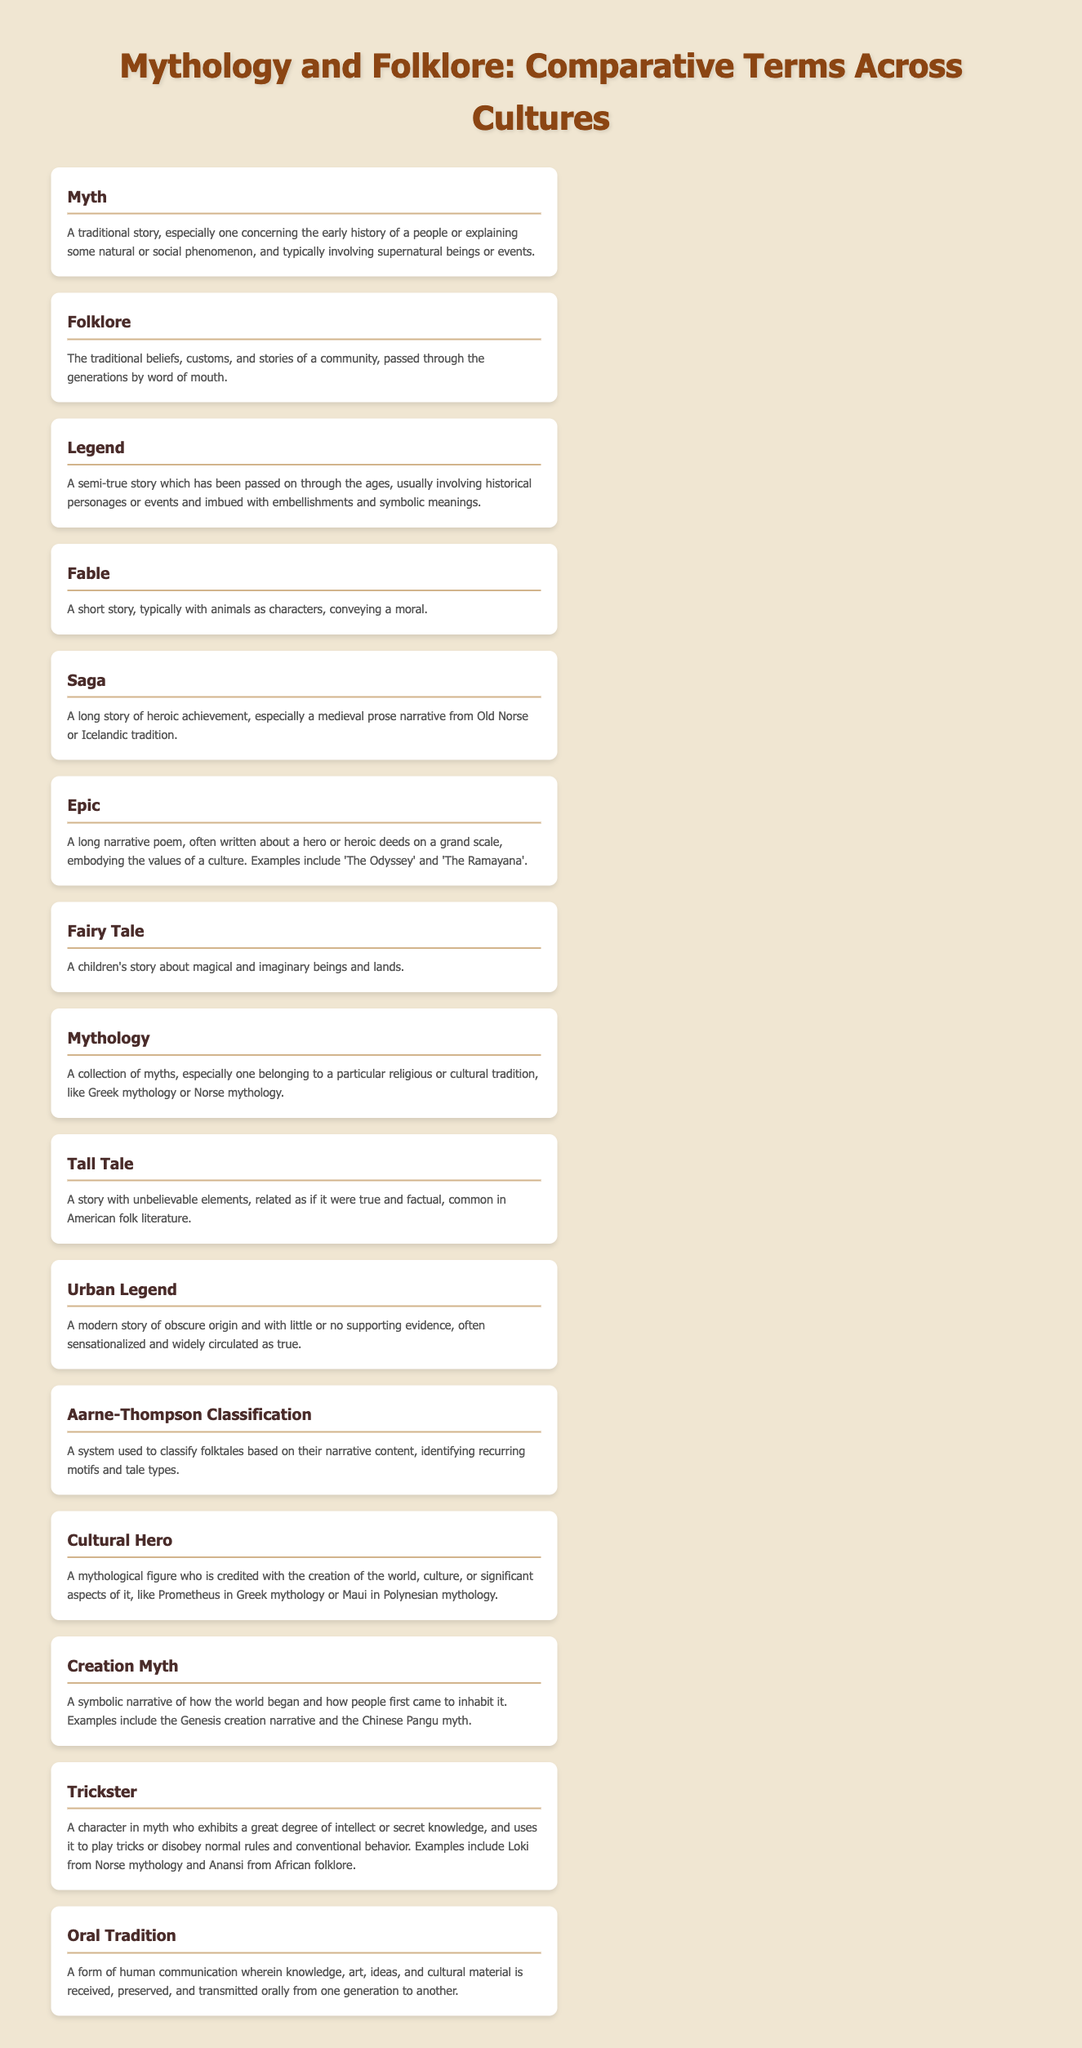What is the title of the document? The title of the document is displayed prominently at the top of the rendered page.
Answer: Mythology and Folklore: Comparative Terms Across Cultures What is a myth? The definition of a myth is provided in the glossary section.
Answer: A traditional story, especially one concerning the early history of a people or explaining some natural or social phenomenon, and typically involving supernatural beings or events How is a legend defined? The glossary entry outlines how a legend is defined.
Answer: A semi-true story which has been passed on through the ages, usually involving historical personages or events and imbued with embellishments and symbolic meanings What type of characters are typically found in fables? The definition of a fable specifies the type of characters involved.
Answer: Animals What is the Aarne-Thompson Classification used for? The glossary explains the purpose of Aarne-Thompson Classification in the definition.
Answer: To classify folktales based on their narrative content Name a mythological figure considered a cultural hero. The glossary lists examples of cultural heroes.
Answer: Prometheus What does oral tradition involve? The definition in the glossary provides insight into oral tradition.
Answer: A form of human communication wherein knowledge, art, ideas, and cultural material is received, preserved, and transmitted orally from one generation to another What narrative type is a fairy tale? The glossary defines what kind of story a fairy tale is categorized under.
Answer: A children's story about magical and imaginary beings and lands What is a common characteristic of a trickster in mythology? The definition provided indicates a common trait of tricksters.
Answer: Exhibits a great degree of intellect or secret knowledge 